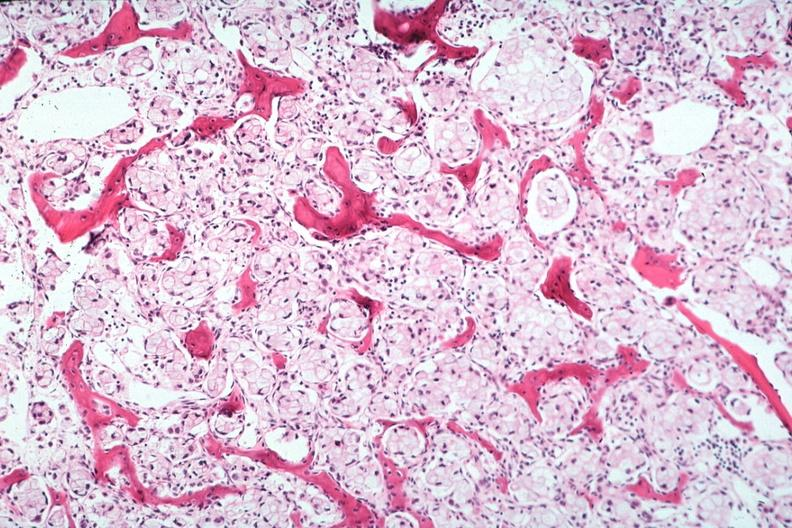does this image show stomach primary?
Answer the question using a single word or phrase. Yes 